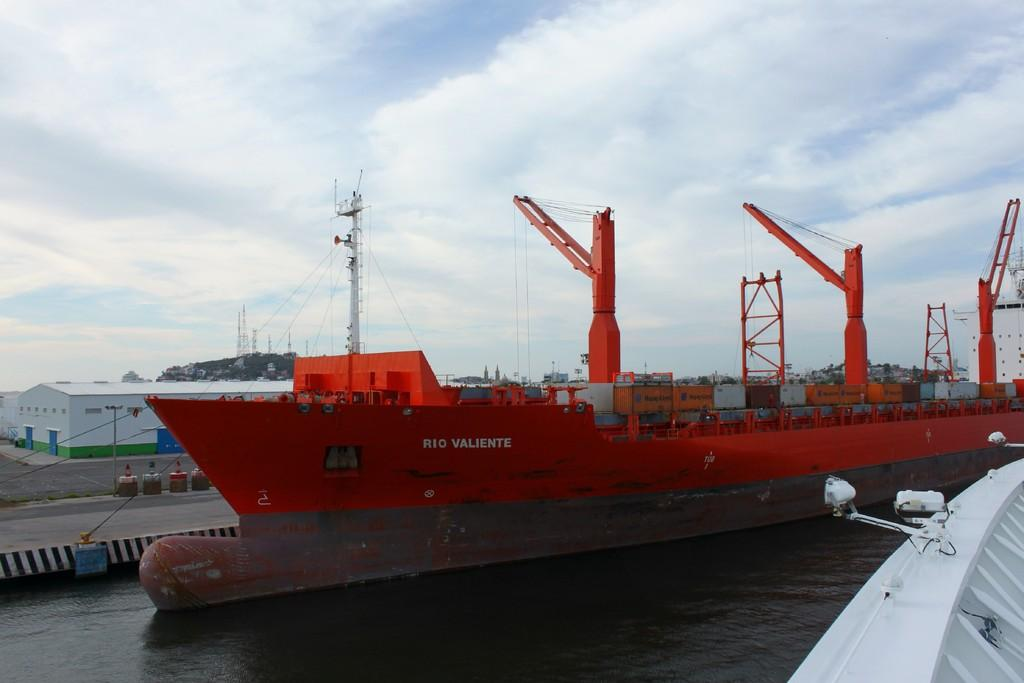<image>
Create a compact narrative representing the image presented. A large red container ship named Rio Valiente 